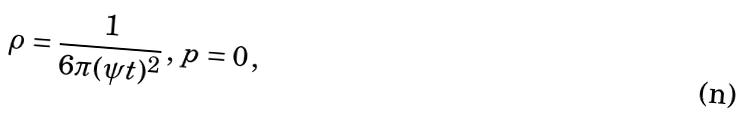<formula> <loc_0><loc_0><loc_500><loc_500>\rho = \frac { 1 } { 6 \pi ( \psi t ) ^ { 2 } } \, , \, p = 0 \, ,</formula> 